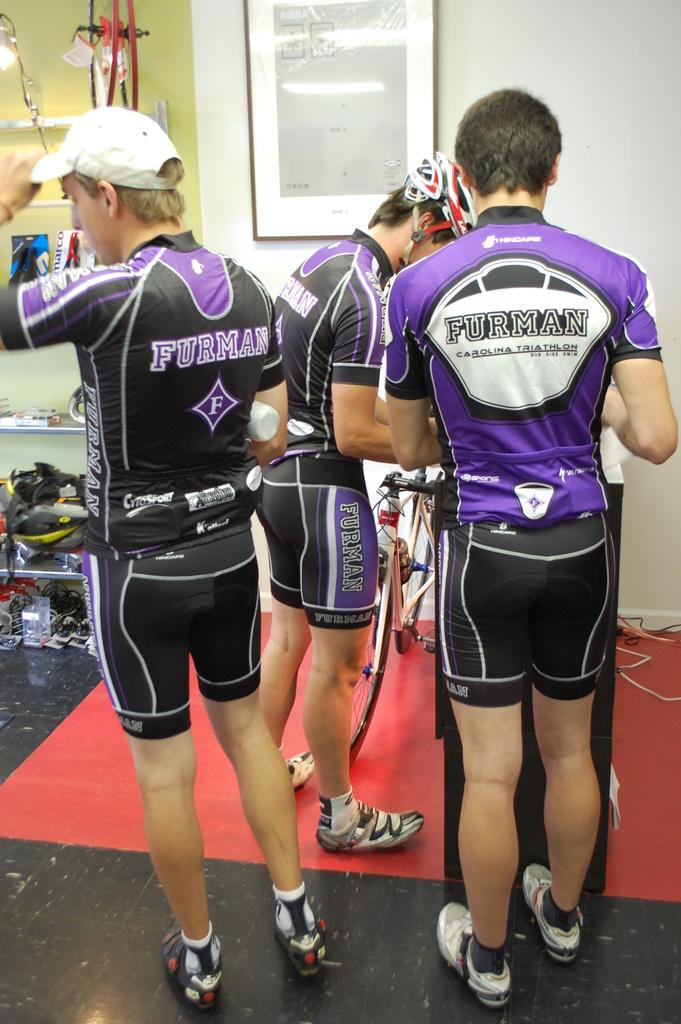<image>
Render a clear and concise summary of the photo. Three athletic bicycle racers with Furman wear on 